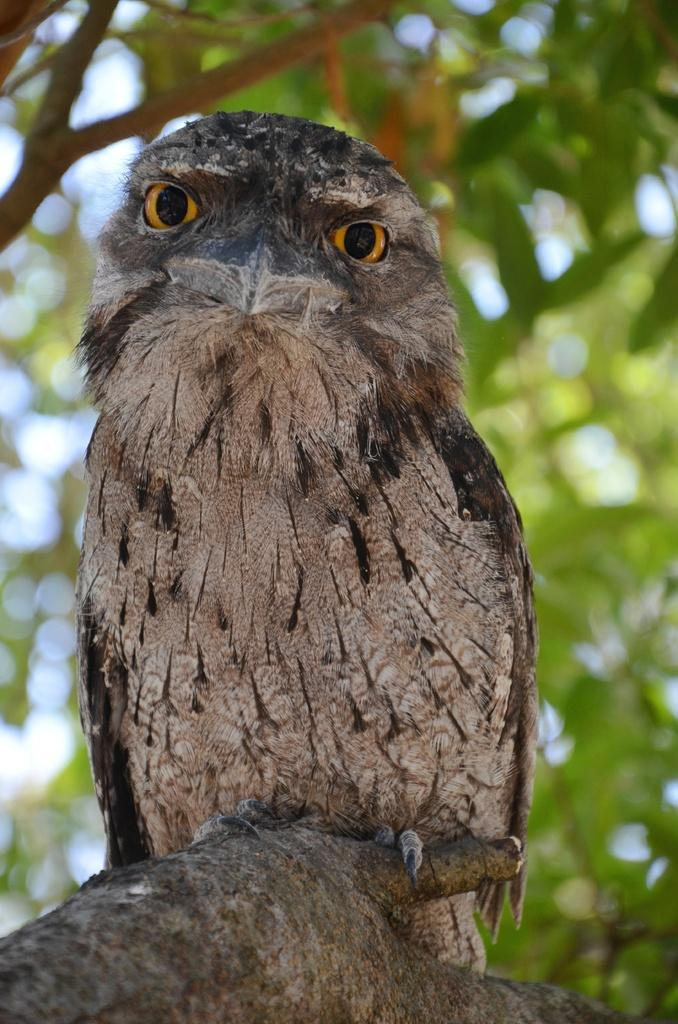What animal is featured in the image? There is an owl in the image. Where is the owl located? The owl is sitting on a tree branch. What can be seen in the background of the image? There are trees and the sky visible in the background of the image. Can you determine the time of day the image was taken? The image was likely taken during the day, as the sky is visible and there is no indication of darkness. What type of smoke can be seen coming from the owl's beak in the image? There is no smoke coming from the owl's beak in the image. How many cattle are visible in the image? There are no cattle present in the image. 